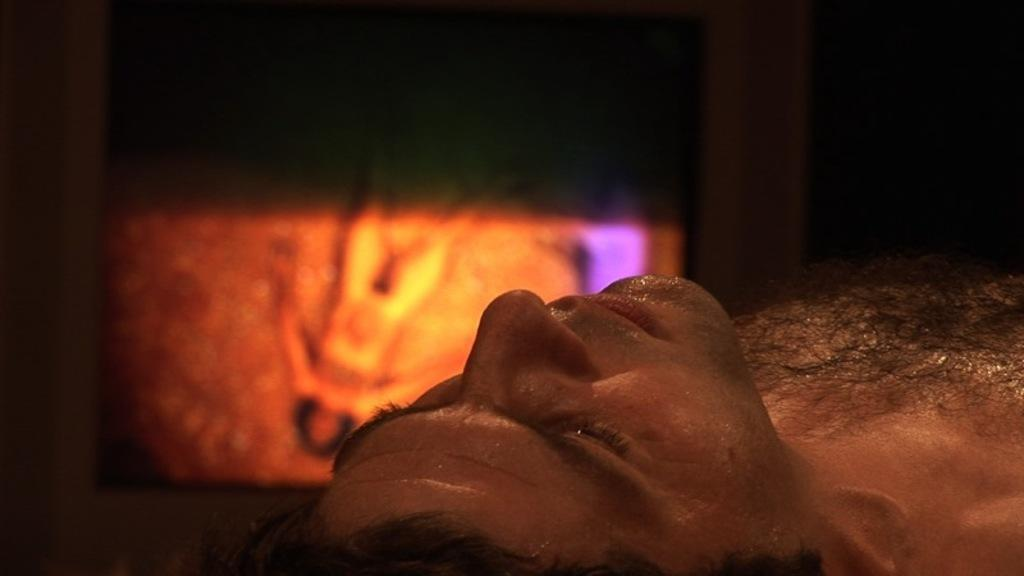What is the person in the image doing? The person is lying down in the image. What can be observed about the background of the image? The background of the image is blurred. What object is visible in the image besides the person? There is a screen visible in the image. What type of pie is being served on the person's legs in the image? There is no pie or legs visible in the image; the person is lying down, and the background is blurred. 